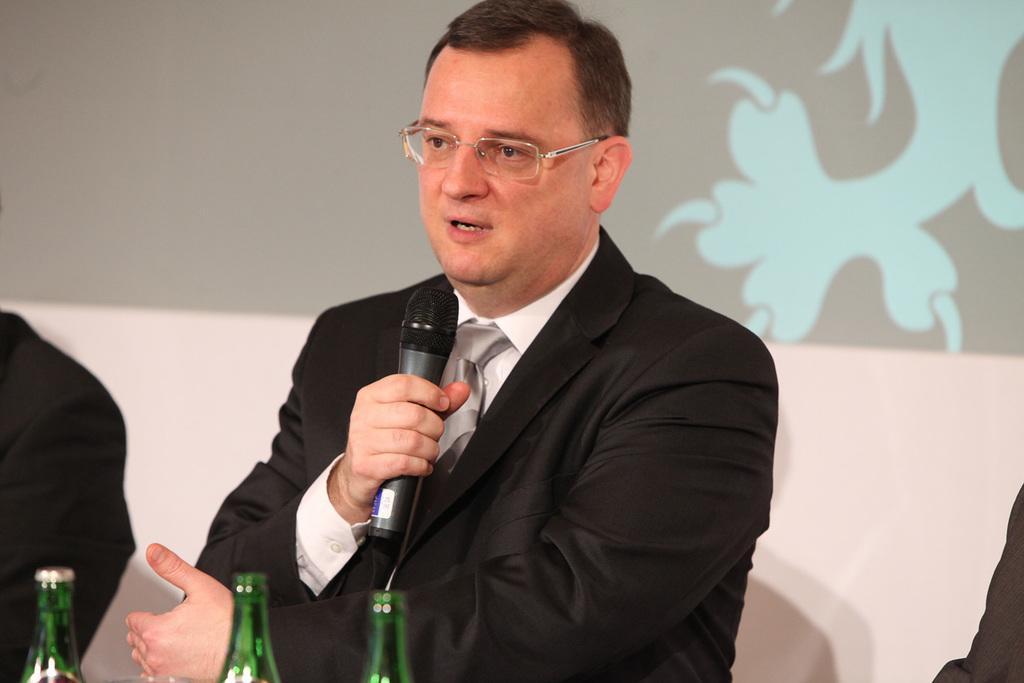Can you describe this image briefly? A person in black dress is holding a mic and speaking. He is wearing spectacles. There are three green bottles in front of him. 